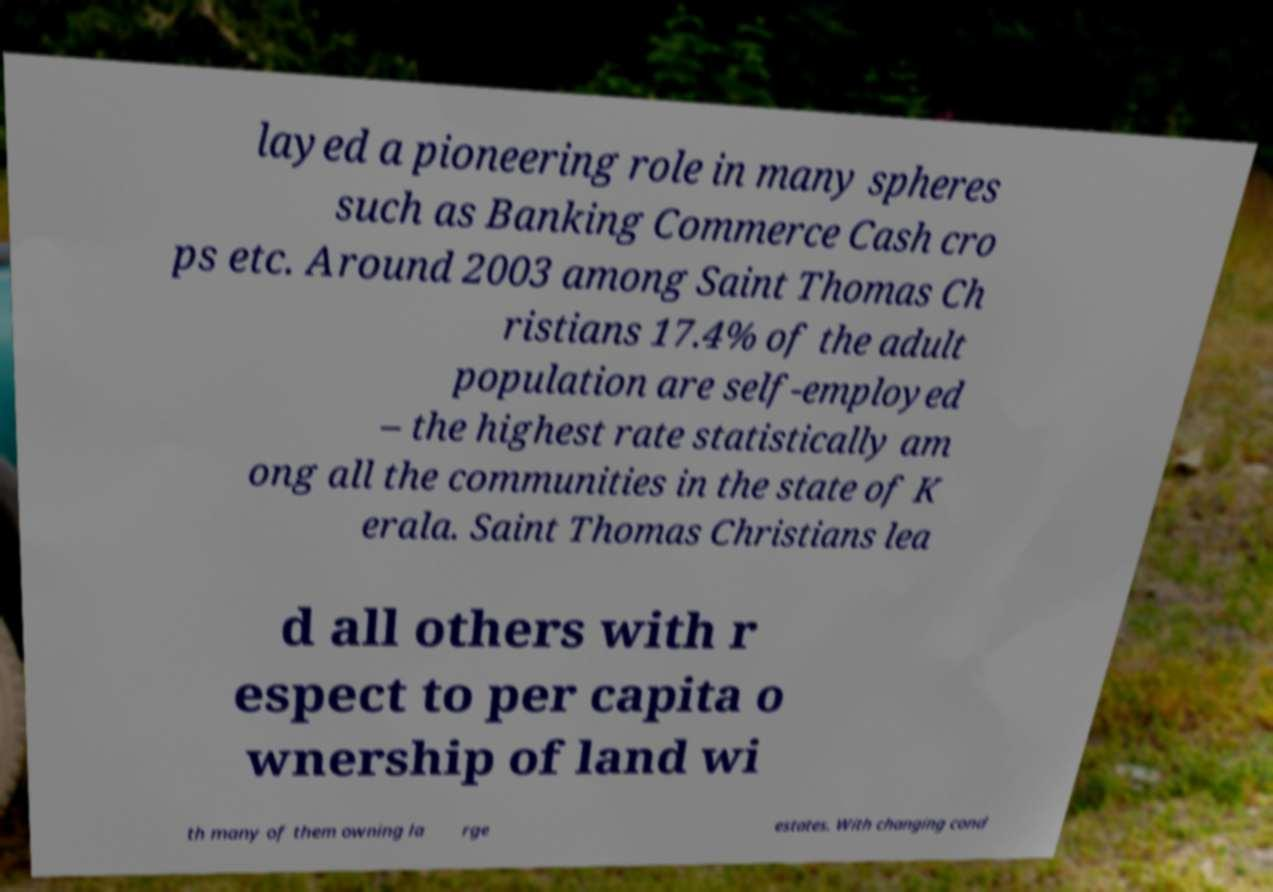Please identify and transcribe the text found in this image. layed a pioneering role in many spheres such as Banking Commerce Cash cro ps etc. Around 2003 among Saint Thomas Ch ristians 17.4% of the adult population are self-employed – the highest rate statistically am ong all the communities in the state of K erala. Saint Thomas Christians lea d all others with r espect to per capita o wnership of land wi th many of them owning la rge estates. With changing cond 